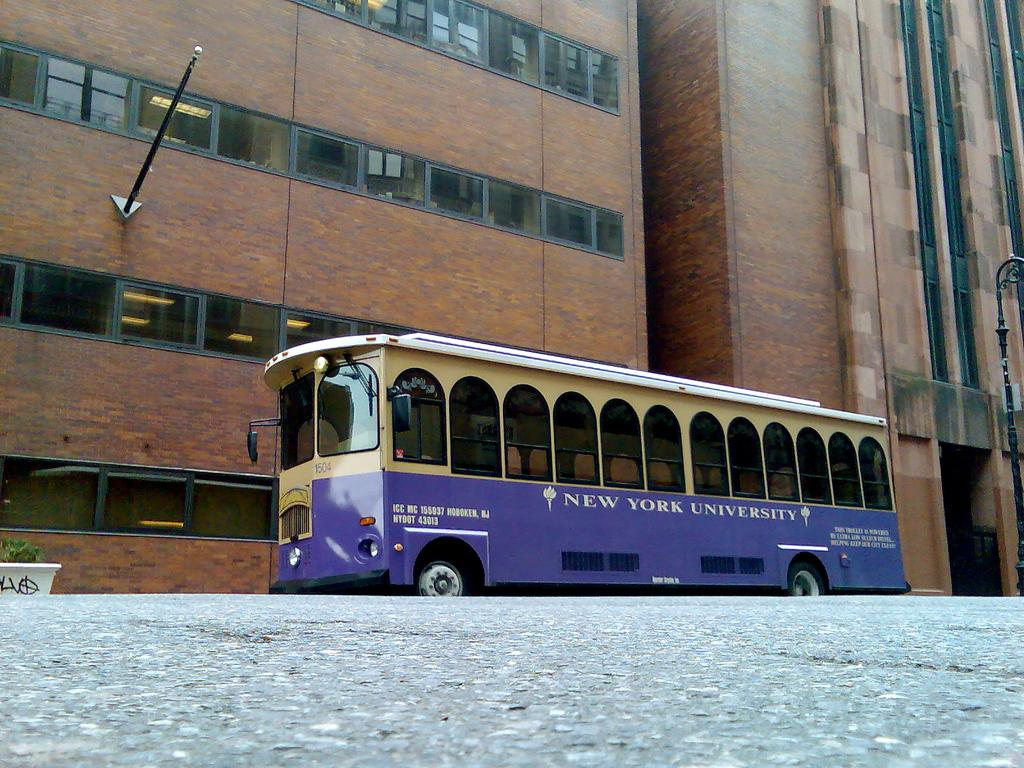What is the main subject of the image? The main subject of the image is a bus. What are some features of the bus? The bus has windows and wheels. Where is the bus located in the image? The bus is on the road. What can be seen in the background of the image? There are buildings with glass windows, a pole in front of a building, and a plant in front of a building. What caption is written on the bus in the image? There is no caption written on the bus in the image. --- Facts: 1. There is a person in the image. 2. The person is wearing a hat. 3. The person is holding a book. 4. The person is standing in front of a bookshelf. 5. The bookshelf is filled with books. Absurd Topics: elephant, piano, dance Conversation: Who or what is the main subject in the image? The main subject in the image is a person. What is the person wearing in the image? The person is wearing a hat in the image. What is the person holding in the image? The person is holding a book in the image. What is the person standing in front of in the image? The person is standing in front of a bookshelf in the image. What can be seen on the bookshelf in the image? The bookshelf is filled with books in the image. Reasoning: Let's think step by step in order to produce the conversation. We start by identifying the main subject of the image, which is a person. Then, we describe the person's attire, specifically mentioning that they are wearing a hat. Next, we focus on the object that the person is holding, which is a book. After that, we describe the location of the person, which is standing in front of a bookshelf. Finally, we expand the conversation to include details about the bookshelf, which is filled with books. Absurd Question/Answer: Can you hear the elephant playing the piano in the image? There is no elephant or piano present in the image. --- Facts: 1. There is a dog in the image. 2. The dog is sitting on a chair. 3. The chair is located in a living room. 4. There is a fireplace in the living room. 5. The fireplace has a mantel. Absurd Topics: ice cream, skateboard, snow Conversation: What is the main subject in the image? The main subject in the image is a dog. What is the dog doing in the image? The dog is sitting on a chair in the image. Where is the chair located in the image? The 